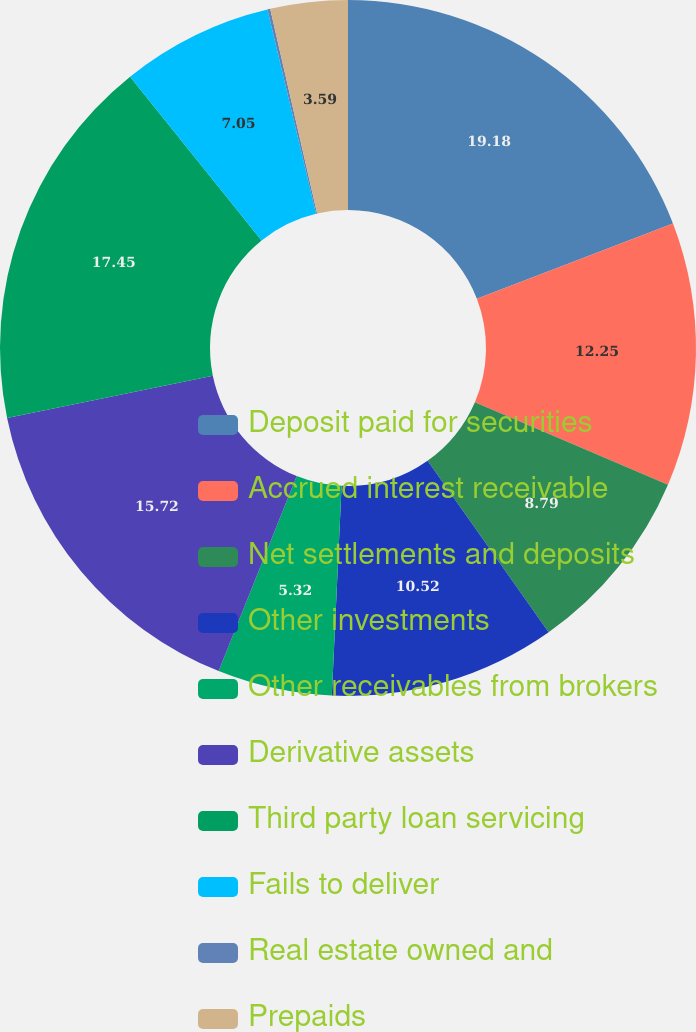Convert chart to OTSL. <chart><loc_0><loc_0><loc_500><loc_500><pie_chart><fcel>Deposit paid for securities<fcel>Accrued interest receivable<fcel>Net settlements and deposits<fcel>Other investments<fcel>Other receivables from brokers<fcel>Derivative assets<fcel>Third party loan servicing<fcel>Fails to deliver<fcel>Real estate owned and<fcel>Prepaids<nl><fcel>19.18%<fcel>12.25%<fcel>8.79%<fcel>10.52%<fcel>5.32%<fcel>15.72%<fcel>17.45%<fcel>7.05%<fcel>0.13%<fcel>3.59%<nl></chart> 